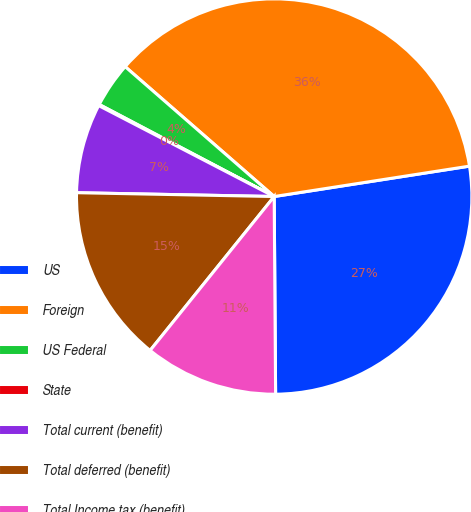Convert chart. <chart><loc_0><loc_0><loc_500><loc_500><pie_chart><fcel>US<fcel>Foreign<fcel>US Federal<fcel>State<fcel>Total current (benefit)<fcel>Total deferred (benefit)<fcel>Total Income tax (benefit)<nl><fcel>27.34%<fcel>36.13%<fcel>3.7%<fcel>0.1%<fcel>7.3%<fcel>14.51%<fcel>10.91%<nl></chart> 